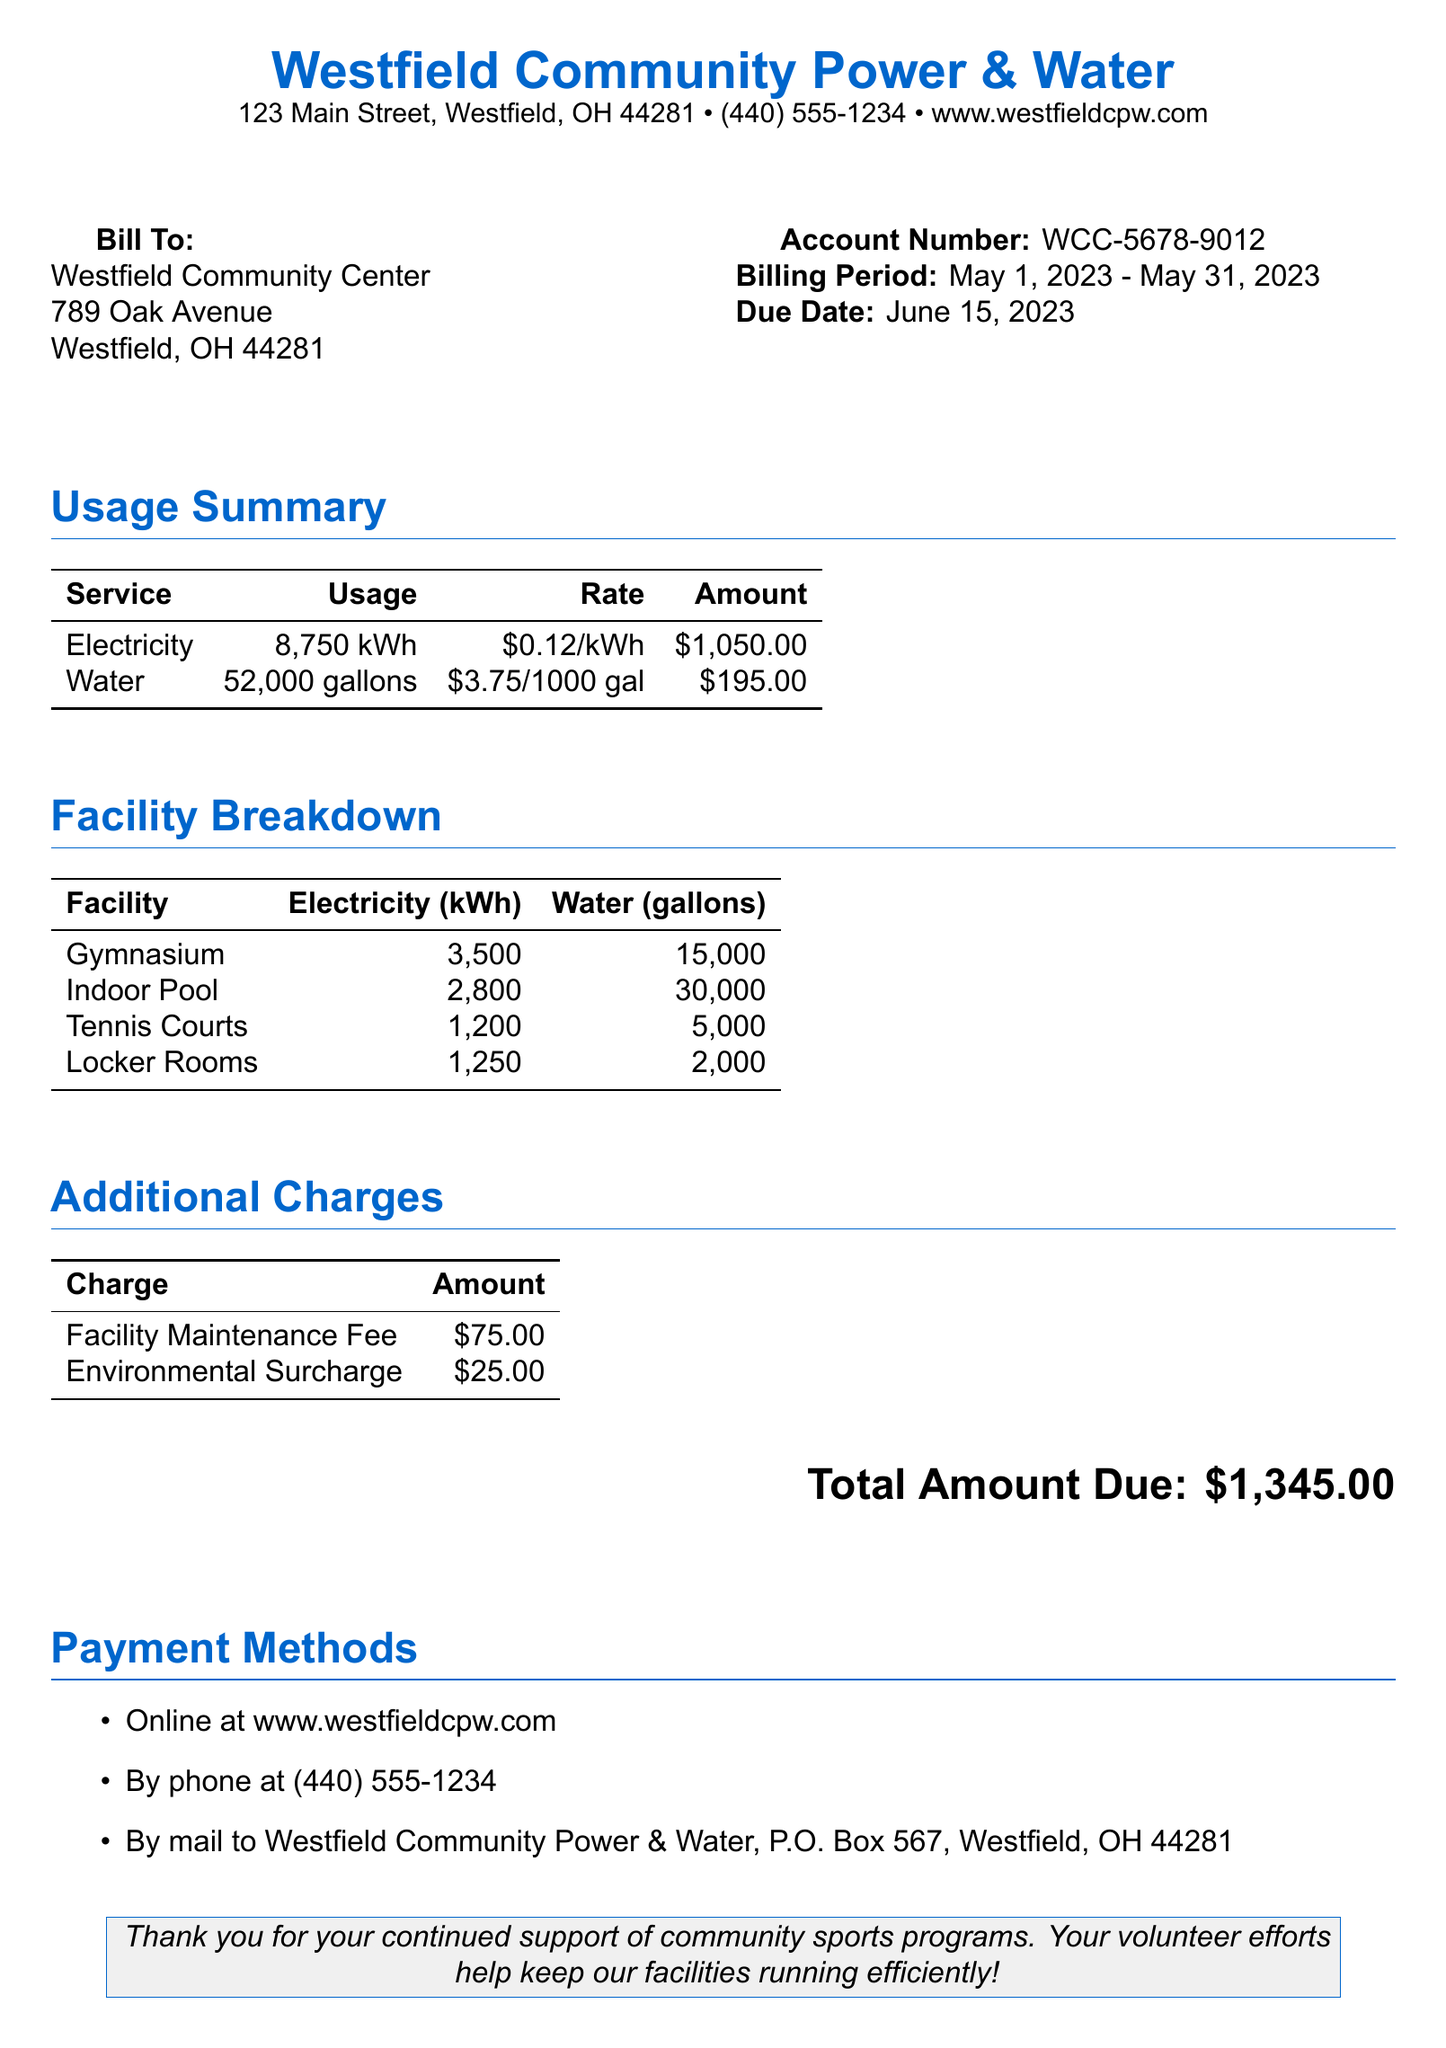What is the account number? The account number is provided in the document to identify the billing account for the community center.
Answer: WCC-5678-9012 What is the billing period? The billing period specifies the time frame for which the bill is calculated.
Answer: May 1, 2023 - May 31, 2023 How much electricity was used? The document lists the total electricity usage for the community center.
Answer: 8,750 kWh What is the total amount due? The total amount due is the final amount that needs to be paid for the services rendered in the billing period.
Answer: $1,345.00 Which facility used the most water? The document provides a breakdown of water usage by facility, and this facility had the highest amount.
Answer: Indoor Pool How much is the Facility Maintenance Fee? This fee is one of the additional charges listed in the document and contributes to the total amount due.
Answer: $75.00 What is the rate for water usage? The rate for water usage is specified in the usage summary table and is charged per 1,000 gallons.
Answer: $3.75/1000 gal What service has the highest amount charged? This question requires comparing the amounts charged for each service listed.
Answer: Electricity What payment methods are available? The document lists several options for making the payment, emphasizing the variety of choices available.
Answer: Online, By phone, By mail 